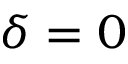<formula> <loc_0><loc_0><loc_500><loc_500>\delta = 0</formula> 